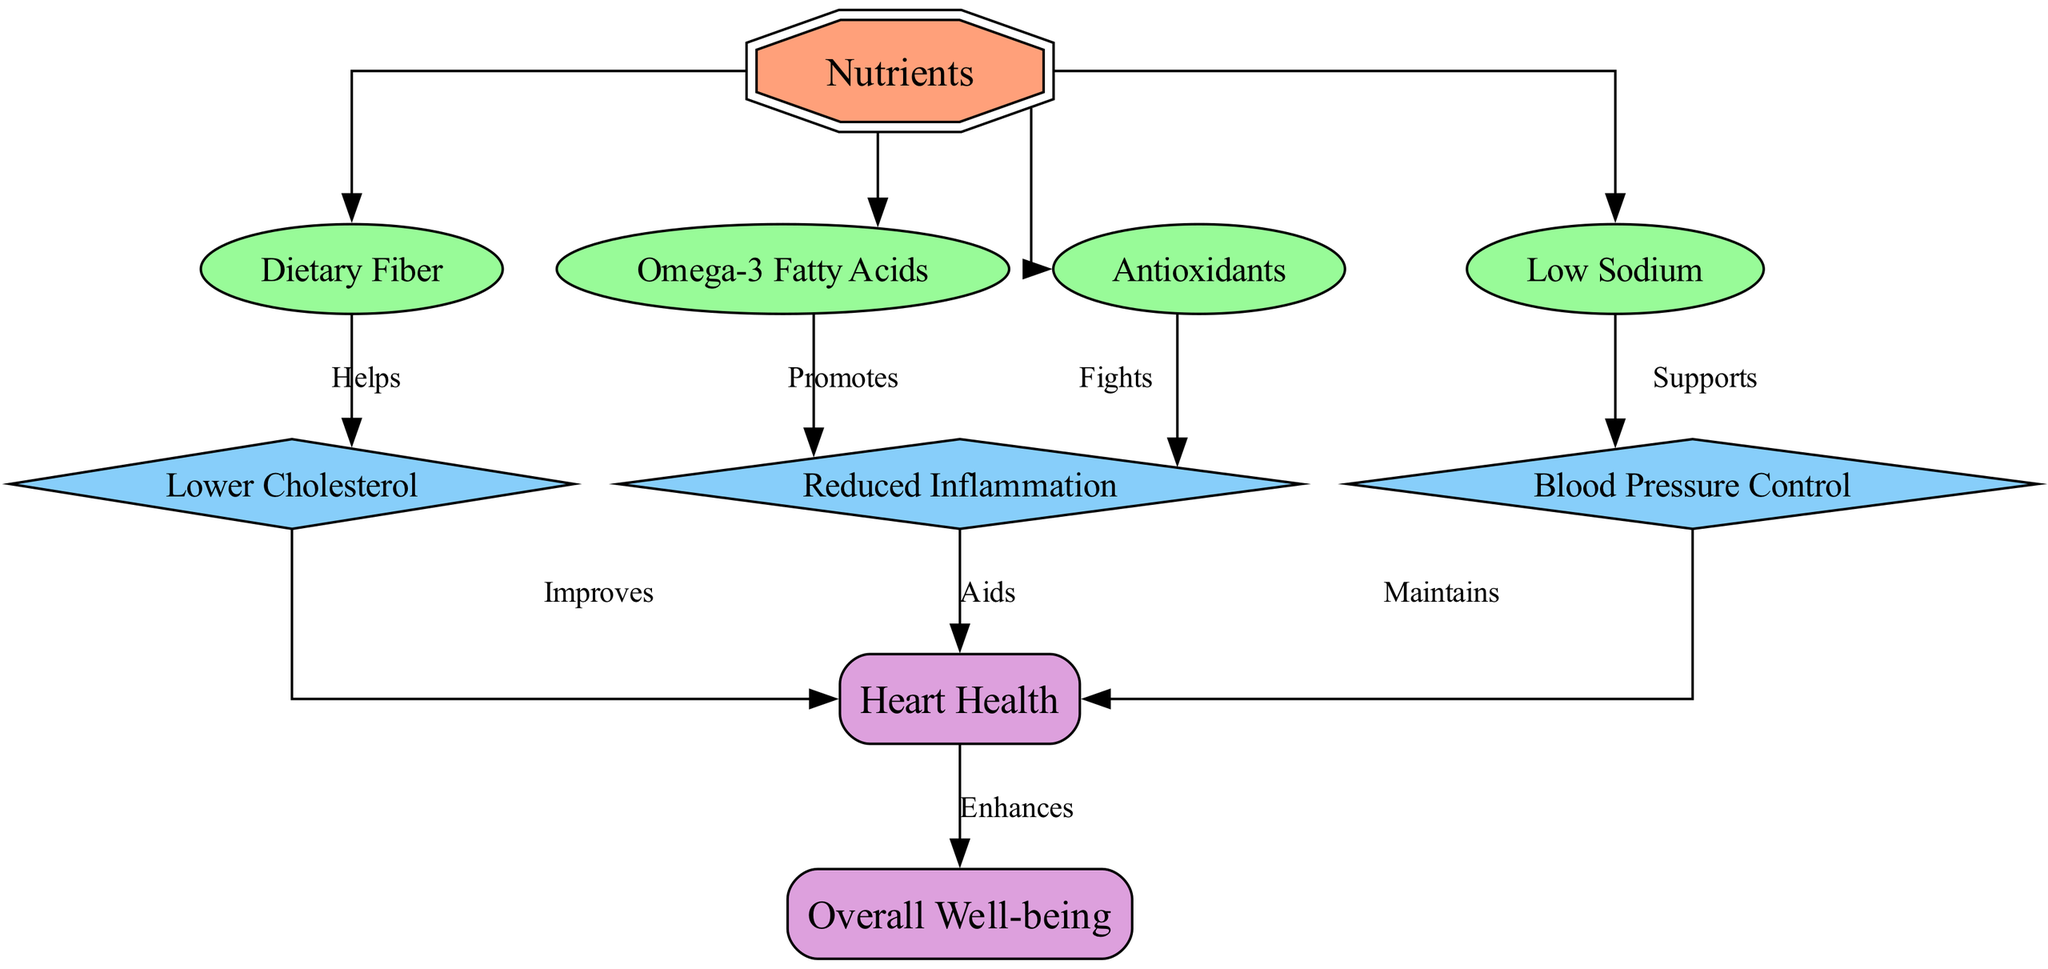What are the four types of nutrients shown in the diagram? The diagram lists Omega-3 Fatty Acids, Dietary Fiber, Antioxidants, and Low Sodium as the four nutrients contributing to heart health.
Answer: Omega-3 Fatty Acids, Dietary Fiber, Antioxidants, Low Sodium How many edges are present in the diagram? The diagram depicts a total of 11 edges connecting various nodes, indicating relationships between nutrients, benefits, and outcomes.
Answer: 11 Which nutrient is indicated as promoting reduced inflammation? The diagram shows that Omega-3 Fatty Acids are linked to reduced inflammation, highlighting their beneficial effect in heart health.
Answer: Omega-3 Fatty Acids What benefit does dietary fiber help achieve? Dietary Fiber is connected to Lower Cholesterol in the diagram, suggesting its role in cholesterol management and heart health.
Answer: Lower Cholesterol Which outcome is enhanced according to the diagram? The final output noted in the diagram is Overall Well-being, which is enhanced through improved heart health.
Answer: Overall Well-being What does low sodium support according to the diagram? The diagram indicates that Low Sodium supports Blood Pressure Control, illustrating its importance in managing heart health.
Answer: Blood Pressure Control How does reduced inflammation affect heart health? The diagram shows that Reduced Inflammation aids Heart Health, demonstrating the interconnectedness of these factors in cardiovascular care.
Answer: Aids How many benefits are directly linked to heart health? There are three identified benefits: Reduced Inflammation, Lower Cholesterol, and Blood Pressure Control, all linking to the overall heart health outcome.
Answer: 3 Which nutrient fights reduced inflammation? Antioxidants are shown in the diagram to fight reduced inflammation, indicating their protective role in heart health.
Answer: Antioxidants 